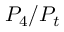<formula> <loc_0><loc_0><loc_500><loc_500>P _ { 4 } / P _ { t }</formula> 